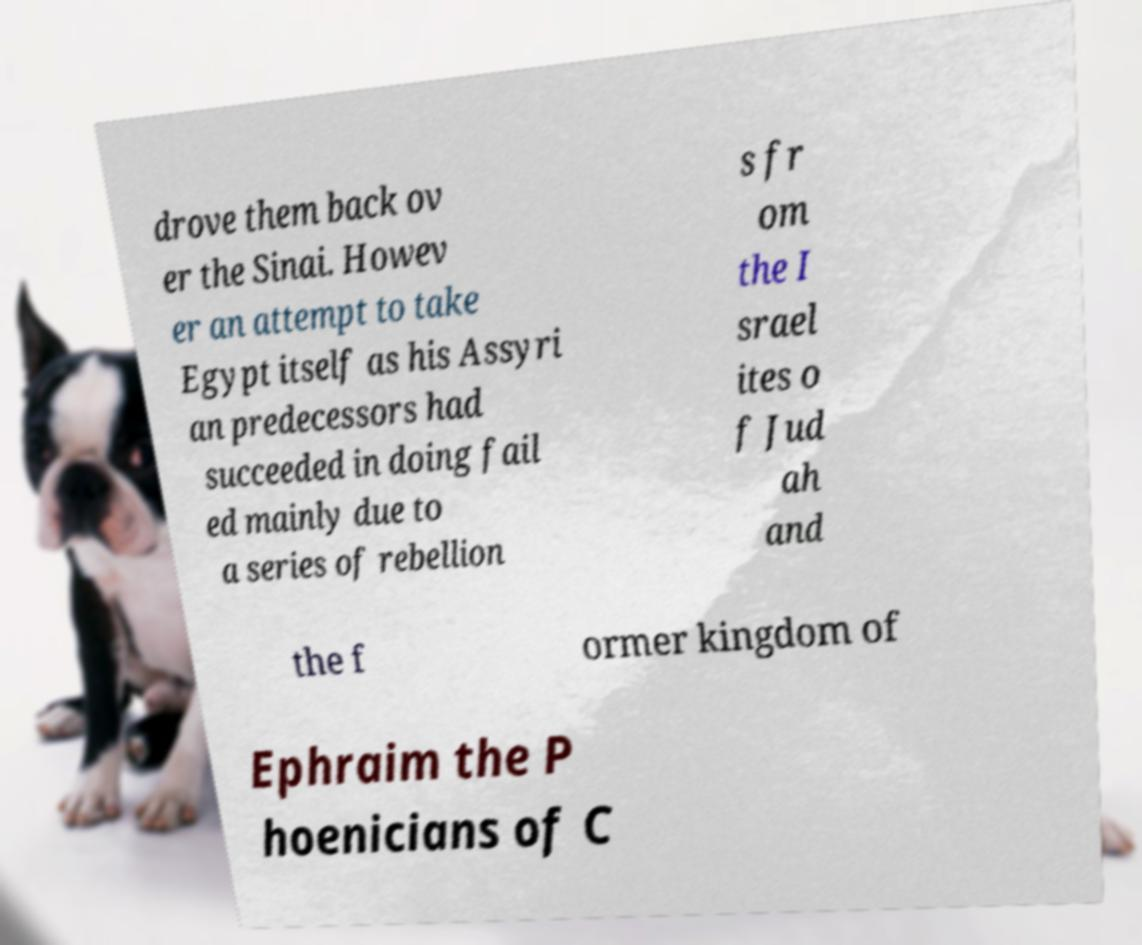I need the written content from this picture converted into text. Can you do that? drove them back ov er the Sinai. Howev er an attempt to take Egypt itself as his Assyri an predecessors had succeeded in doing fail ed mainly due to a series of rebellion s fr om the I srael ites o f Jud ah and the f ormer kingdom of Ephraim the P hoenicians of C 